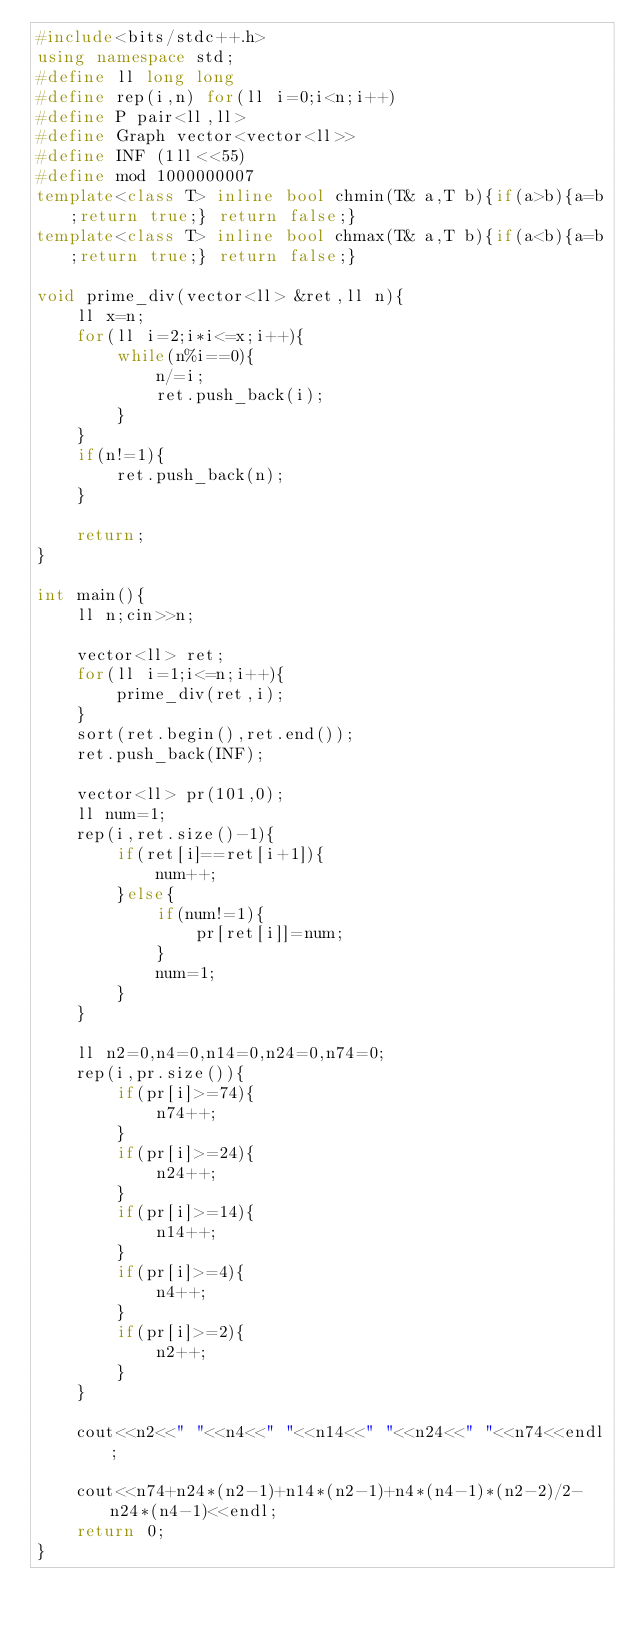<code> <loc_0><loc_0><loc_500><loc_500><_C++_>#include<bits/stdc++.h>
using namespace std;
#define ll long long
#define rep(i,n) for(ll i=0;i<n;i++)
#define P pair<ll,ll>
#define Graph vector<vector<ll>>
#define INF (1ll<<55)
#define mod 1000000007
template<class T> inline bool chmin(T& a,T b){if(a>b){a=b;return true;} return false;}
template<class T> inline bool chmax(T& a,T b){if(a<b){a=b;return true;} return false;}

void prime_div(vector<ll> &ret,ll n){
    ll x=n;
    for(ll i=2;i*i<=x;i++){
	    while(n%i==0){
  		    n/=i;
            ret.push_back(i);
	    }
    }
    if(n!=1){ 
	    ret.push_back(n);
    }

    return;
}

int main(){
    ll n;cin>>n;

    vector<ll> ret;
    for(ll i=1;i<=n;i++){
        prime_div(ret,i);
    }
    sort(ret.begin(),ret.end());
    ret.push_back(INF);

    vector<ll> pr(101,0);
    ll num=1;
    rep(i,ret.size()-1){
        if(ret[i]==ret[i+1]){
            num++;
        }else{
            if(num!=1){
                pr[ret[i]]=num;
            }
            num=1;
        }
    }

    ll n2=0,n4=0,n14=0,n24=0,n74=0;
    rep(i,pr.size()){
        if(pr[i]>=74){
            n74++;
        }
        if(pr[i]>=24){
            n24++;
        }
        if(pr[i]>=14){
            n14++;
        }
        if(pr[i]>=4){
            n4++;
        }
        if(pr[i]>=2){
            n2++;
        }
    }

    cout<<n2<<" "<<n4<<" "<<n14<<" "<<n24<<" "<<n74<<endl;

    cout<<n74+n24*(n2-1)+n14*(n2-1)+n4*(n4-1)*(n2-2)/2-n24*(n4-1)<<endl;
    return 0;
}</code> 